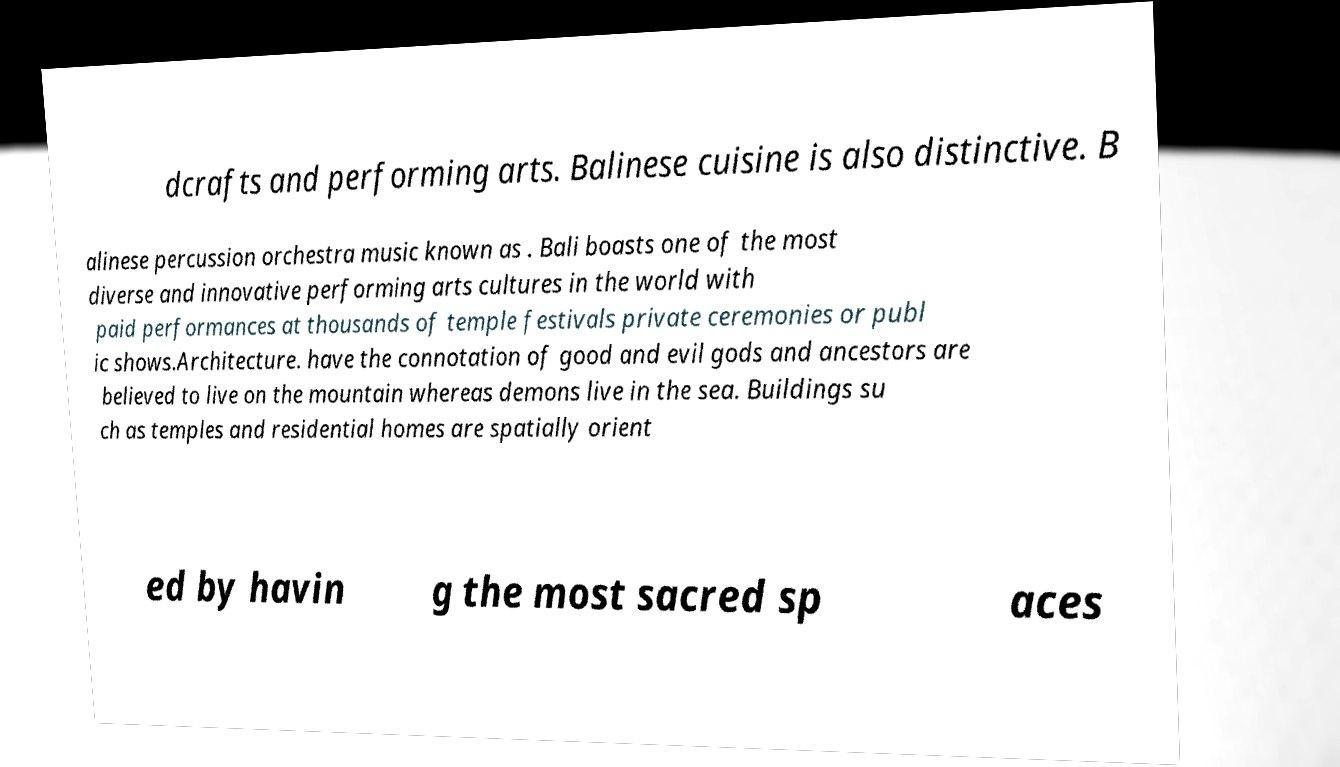Can you read and provide the text displayed in the image?This photo seems to have some interesting text. Can you extract and type it out for me? dcrafts and performing arts. Balinese cuisine is also distinctive. B alinese percussion orchestra music known as . Bali boasts one of the most diverse and innovative performing arts cultures in the world with paid performances at thousands of temple festivals private ceremonies or publ ic shows.Architecture. have the connotation of good and evil gods and ancestors are believed to live on the mountain whereas demons live in the sea. Buildings su ch as temples and residential homes are spatially orient ed by havin g the most sacred sp aces 